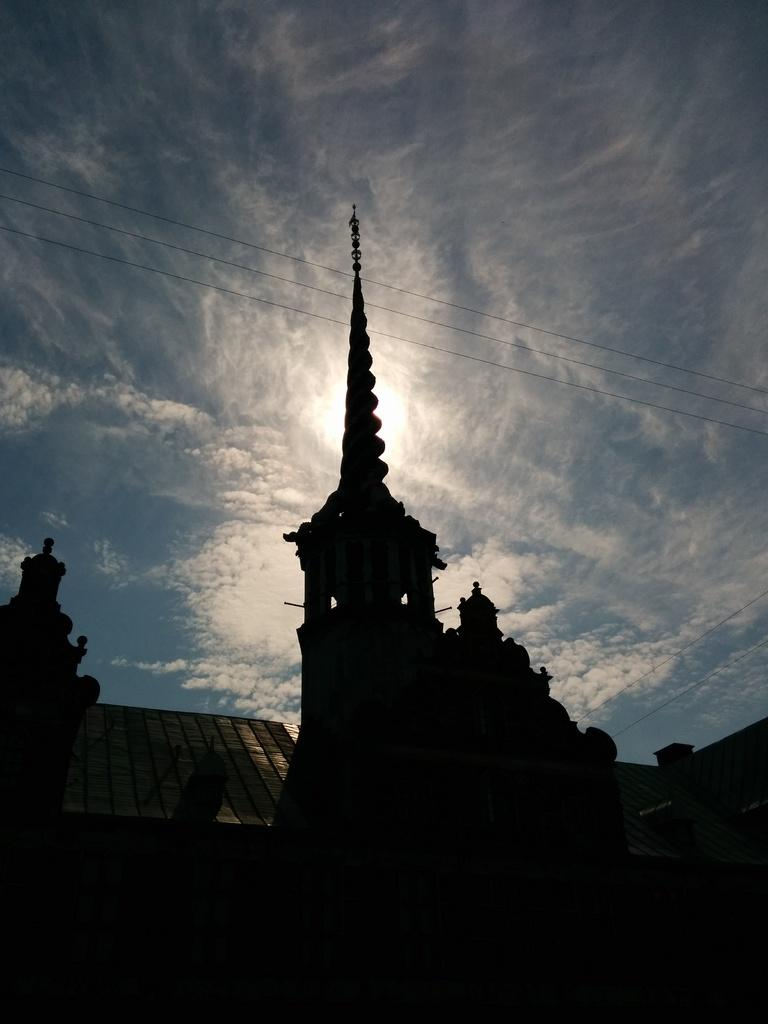What type of location is visible in the image? The image appears to be captured near a temple. What can be seen in the sky at the top of the image? There are clouds visible in the sky. How many berries can be seen growing on the temple in the image? There are no berries present in the image, as it features a scene near a temple with clouds in the sky. 